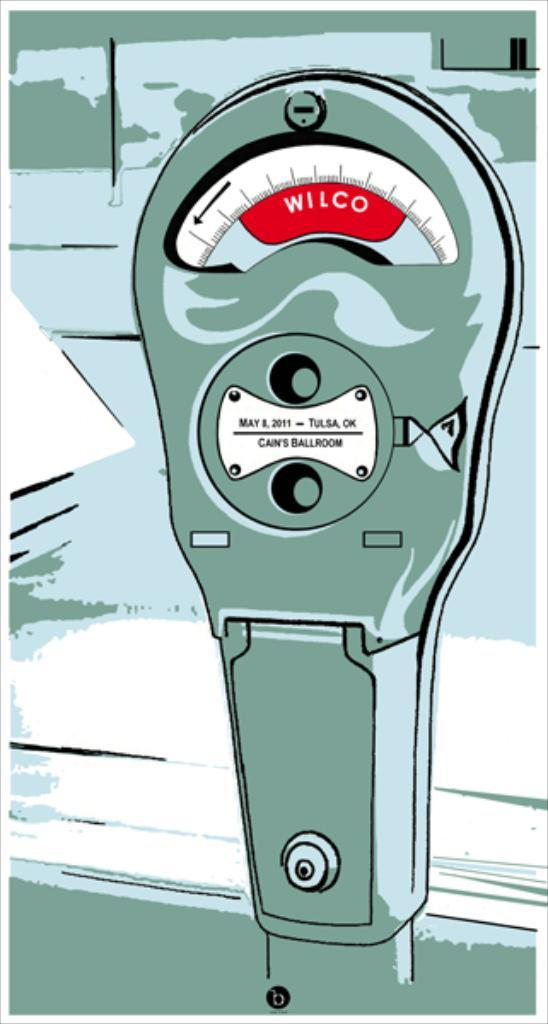<image>
Relay a brief, clear account of the picture shown. An illustration of a parking meter with the word Wilco in a red background. 